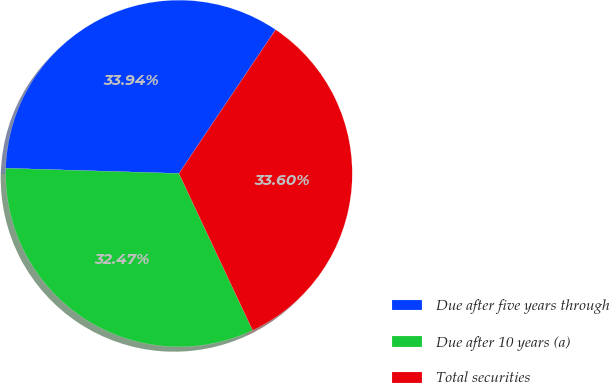Convert chart to OTSL. <chart><loc_0><loc_0><loc_500><loc_500><pie_chart><fcel>Due after five years through<fcel>Due after 10 years (a)<fcel>Total securities<nl><fcel>33.94%<fcel>32.47%<fcel>33.6%<nl></chart> 